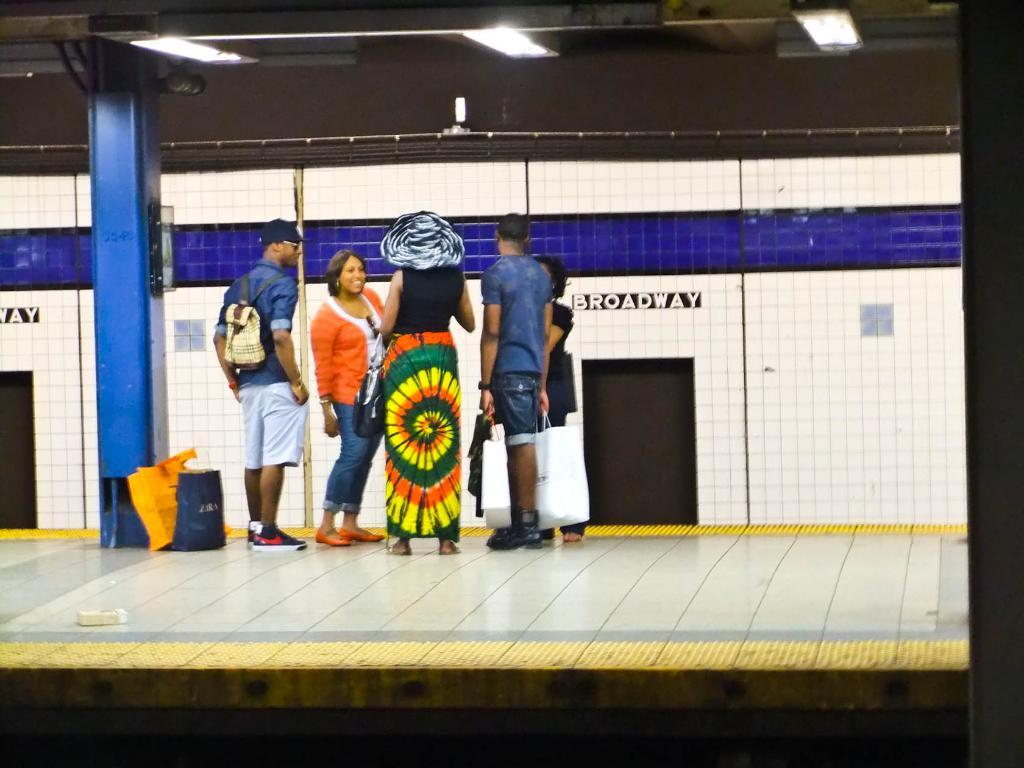What is happening in the image? There are persons standing in the image. Where are the carry bags located in the image? There are two carry bags in the left corner of the image. What can be seen in the background of the image? There is a fence in the background of the image. How many bananas are being carried by the donkey in the image? There is no donkey or bananas present in the image. 